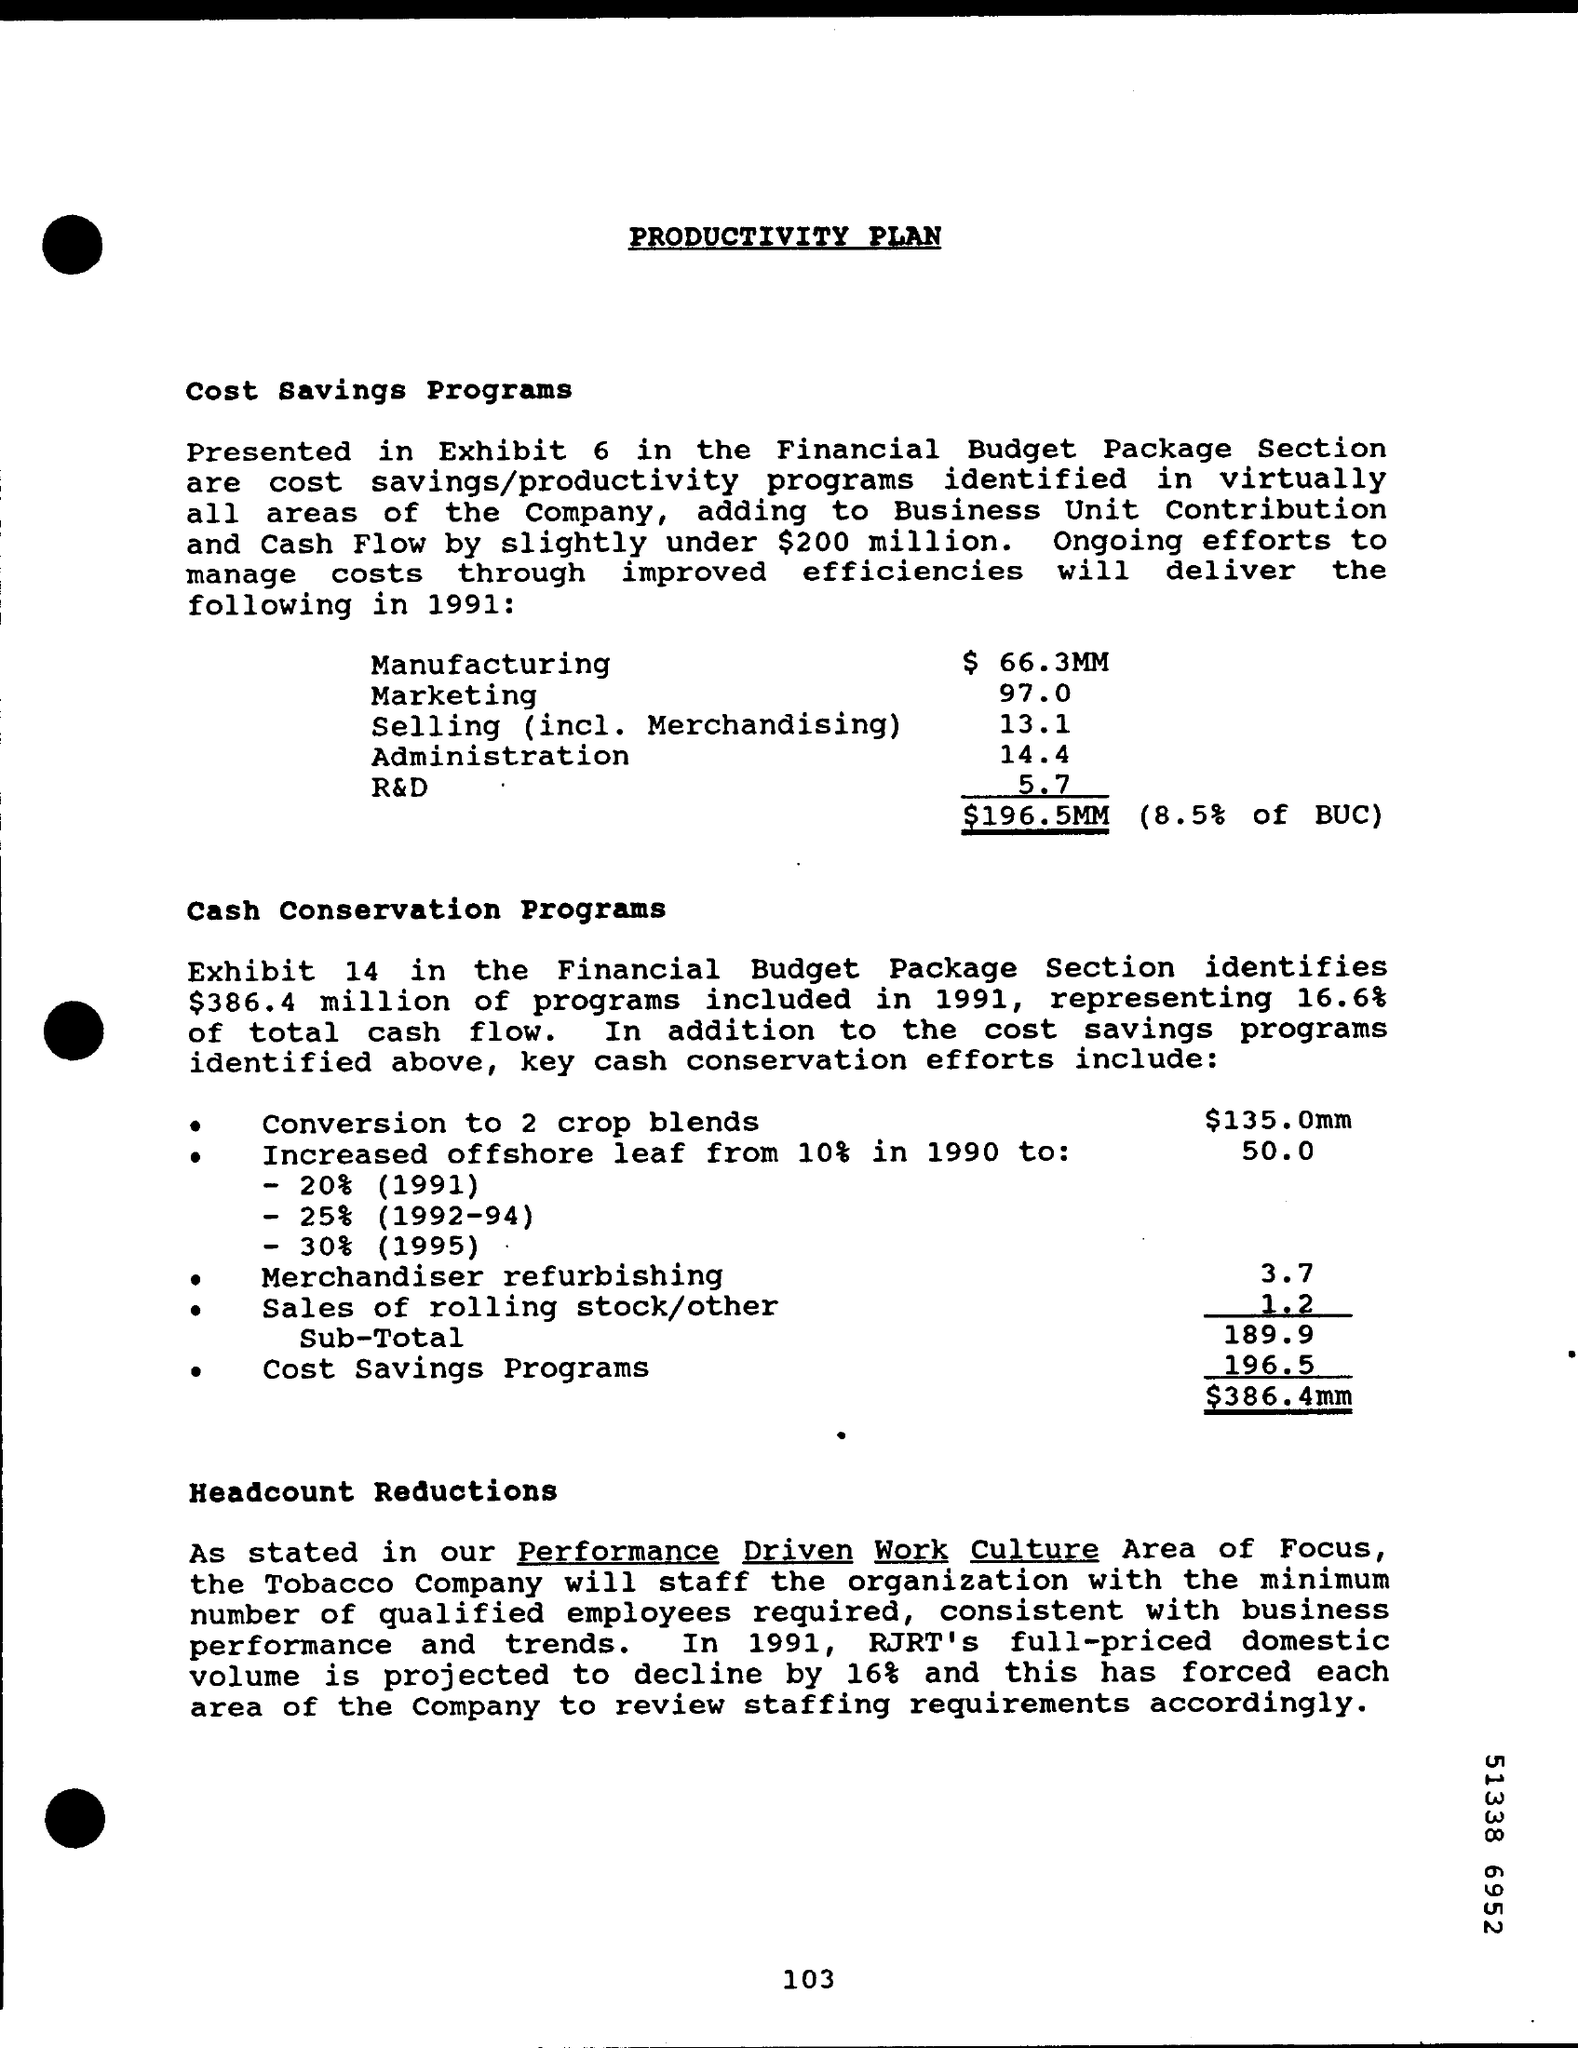Point out several critical features in this image. The total cost savings from the programs is $196.5 million, which represents 8.5% of the budgeted undiscounted cash outflow (BUC). In 1991, RJ Reynolds's full-priced domestic volume is expected to decrease by approximately 16%. 